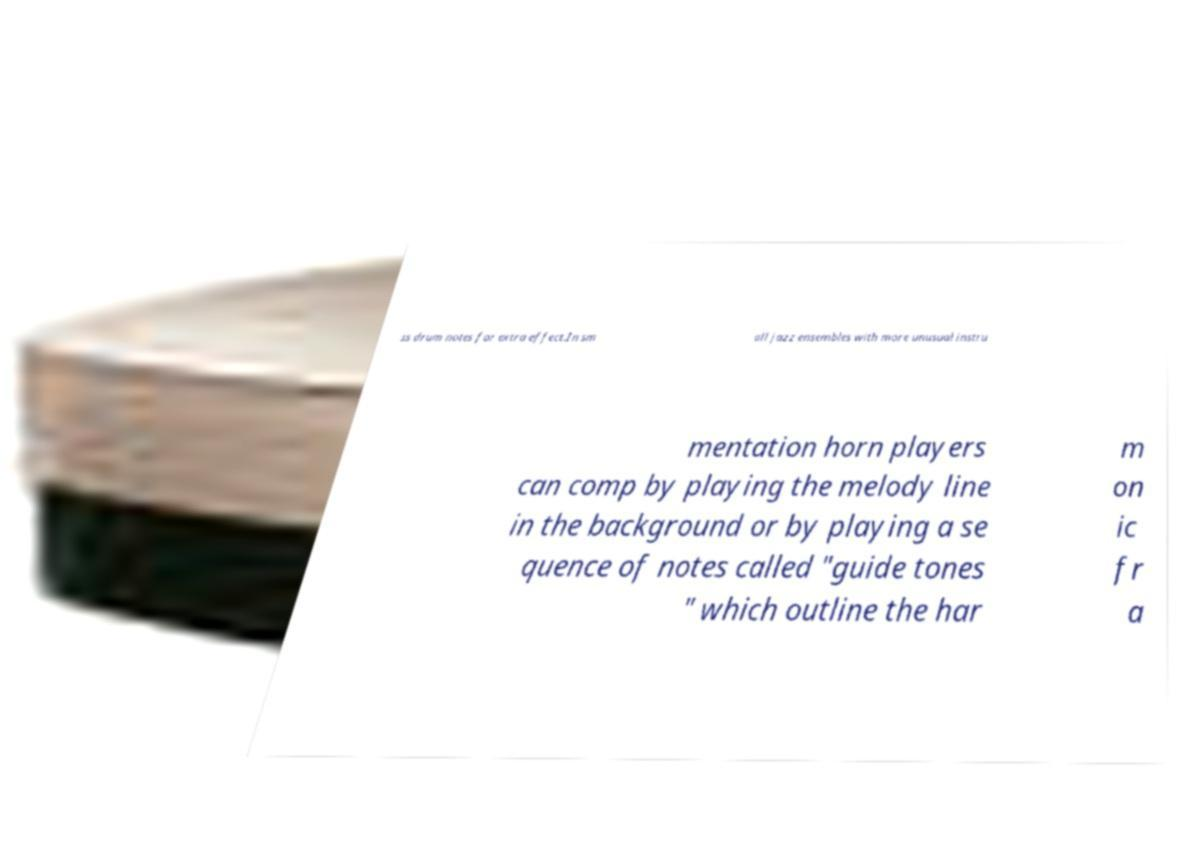Can you read and provide the text displayed in the image?This photo seems to have some interesting text. Can you extract and type it out for me? ss drum notes for extra effect.In sm all jazz ensembles with more unusual instru mentation horn players can comp by playing the melody line in the background or by playing a se quence of notes called "guide tones " which outline the har m on ic fr a 